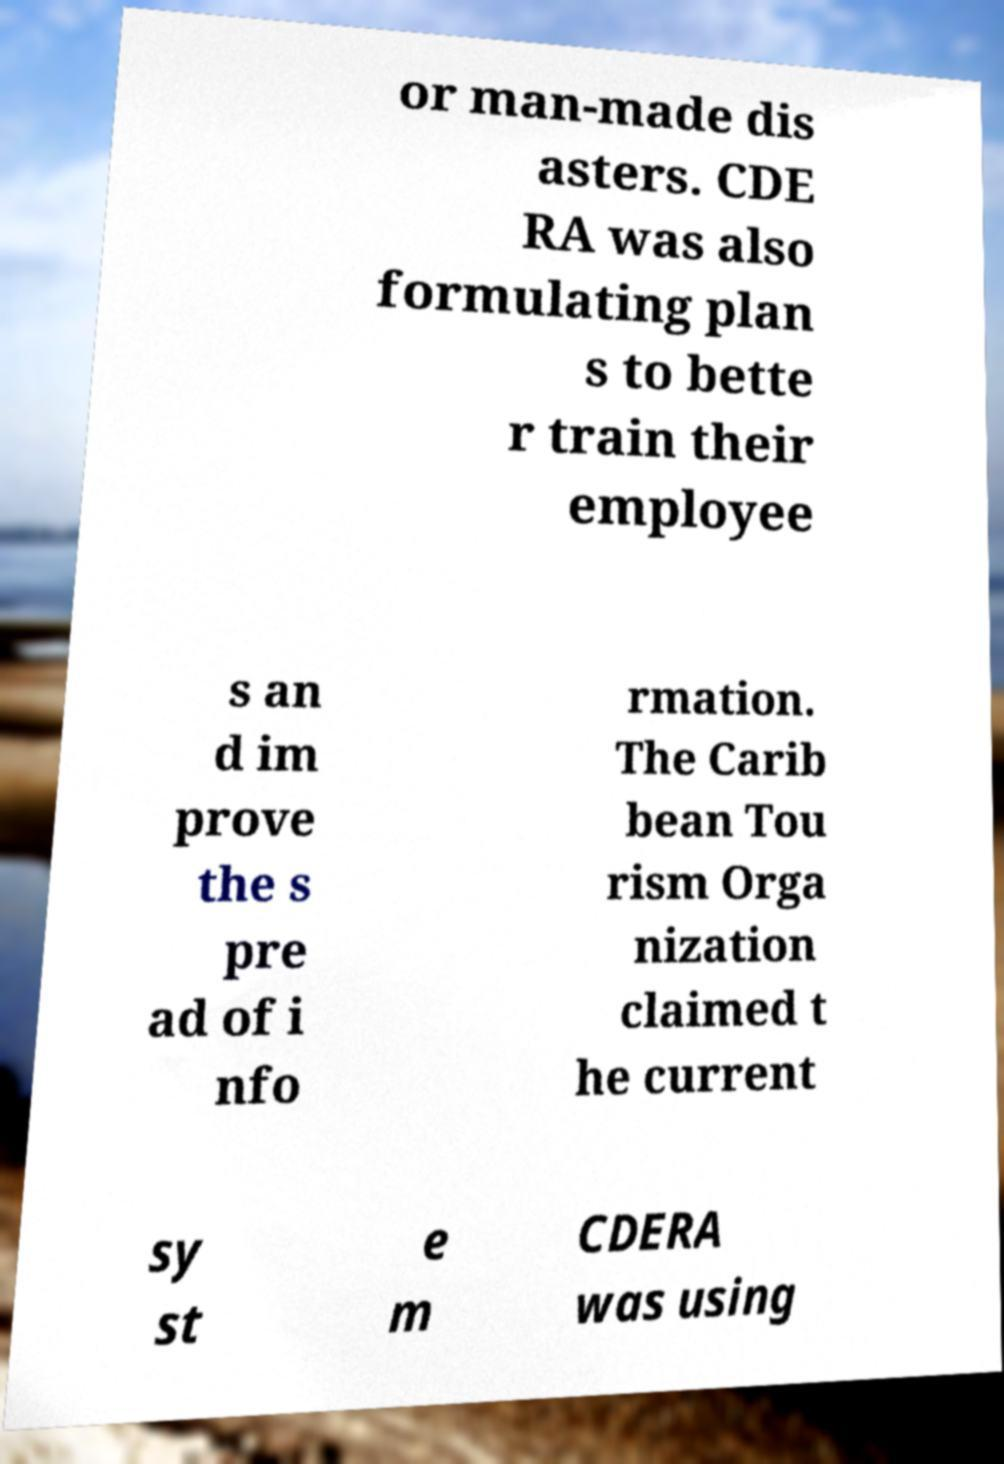Can you accurately transcribe the text from the provided image for me? or man-made dis asters. CDE RA was also formulating plan s to bette r train their employee s an d im prove the s pre ad of i nfo rmation. The Carib bean Tou rism Orga nization claimed t he current sy st e m CDERA was using 